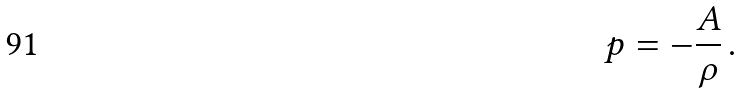Convert formula to latex. <formula><loc_0><loc_0><loc_500><loc_500>p = - \frac { A } { \rho } \, .</formula> 